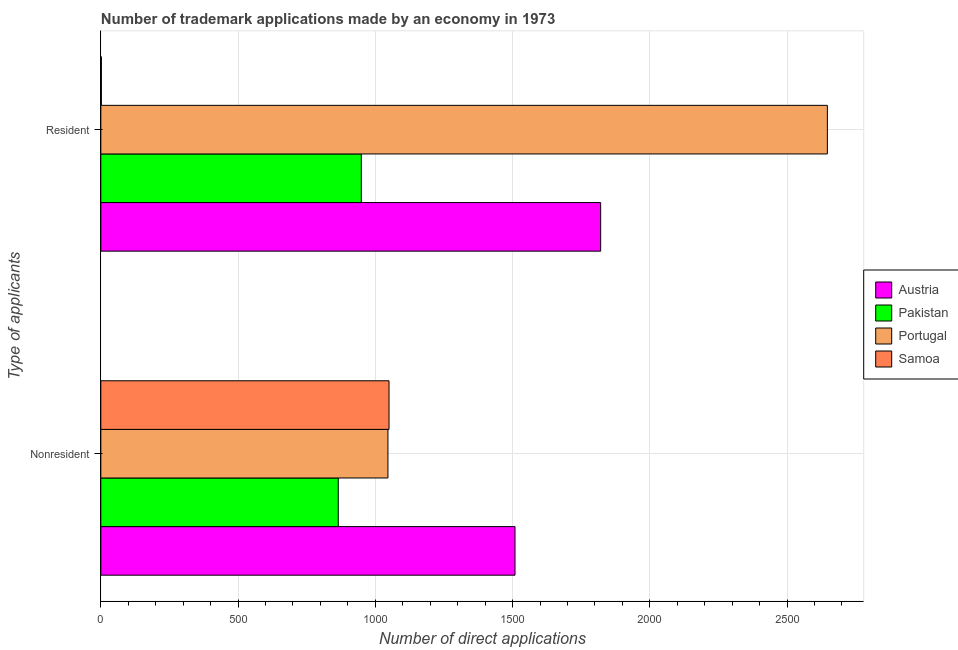How many different coloured bars are there?
Provide a succinct answer. 4. How many groups of bars are there?
Your answer should be compact. 2. Are the number of bars per tick equal to the number of legend labels?
Your answer should be very brief. Yes. Are the number of bars on each tick of the Y-axis equal?
Your response must be concise. Yes. How many bars are there on the 2nd tick from the top?
Your answer should be compact. 4. What is the label of the 1st group of bars from the top?
Offer a very short reply. Resident. What is the number of trademark applications made by non residents in Austria?
Offer a terse response. 1509. Across all countries, what is the maximum number of trademark applications made by non residents?
Keep it short and to the point. 1509. Across all countries, what is the minimum number of trademark applications made by non residents?
Provide a short and direct response. 865. What is the total number of trademark applications made by residents in the graph?
Your answer should be very brief. 5419. What is the difference between the number of trademark applications made by residents in Austria and that in Samoa?
Give a very brief answer. 1819. What is the difference between the number of trademark applications made by residents in Austria and the number of trademark applications made by non residents in Samoa?
Ensure brevity in your answer.  771. What is the average number of trademark applications made by residents per country?
Provide a succinct answer. 1354.75. What is the difference between the number of trademark applications made by non residents and number of trademark applications made by residents in Samoa?
Ensure brevity in your answer.  1048. What is the ratio of the number of trademark applications made by non residents in Portugal to that in Pakistan?
Make the answer very short. 1.21. Is the number of trademark applications made by non residents in Pakistan less than that in Samoa?
Ensure brevity in your answer.  Yes. What does the 1st bar from the top in Nonresident represents?
Ensure brevity in your answer.  Samoa. What does the 4th bar from the bottom in Nonresident represents?
Keep it short and to the point. Samoa. How many bars are there?
Offer a very short reply. 8. Are all the bars in the graph horizontal?
Provide a succinct answer. Yes. What is the difference between two consecutive major ticks on the X-axis?
Provide a succinct answer. 500. Are the values on the major ticks of X-axis written in scientific E-notation?
Your answer should be very brief. No. Does the graph contain any zero values?
Your response must be concise. No. Where does the legend appear in the graph?
Your response must be concise. Center right. How many legend labels are there?
Your answer should be compact. 4. What is the title of the graph?
Offer a terse response. Number of trademark applications made by an economy in 1973. What is the label or title of the X-axis?
Offer a very short reply. Number of direct applications. What is the label or title of the Y-axis?
Give a very brief answer. Type of applicants. What is the Number of direct applications of Austria in Nonresident?
Keep it short and to the point. 1509. What is the Number of direct applications of Pakistan in Nonresident?
Your answer should be compact. 865. What is the Number of direct applications of Portugal in Nonresident?
Give a very brief answer. 1046. What is the Number of direct applications of Samoa in Nonresident?
Make the answer very short. 1050. What is the Number of direct applications in Austria in Resident?
Keep it short and to the point. 1821. What is the Number of direct applications of Pakistan in Resident?
Your answer should be compact. 949. What is the Number of direct applications in Portugal in Resident?
Keep it short and to the point. 2647. What is the Number of direct applications of Samoa in Resident?
Your answer should be compact. 2. Across all Type of applicants, what is the maximum Number of direct applications of Austria?
Keep it short and to the point. 1821. Across all Type of applicants, what is the maximum Number of direct applications in Pakistan?
Your answer should be compact. 949. Across all Type of applicants, what is the maximum Number of direct applications of Portugal?
Offer a terse response. 2647. Across all Type of applicants, what is the maximum Number of direct applications in Samoa?
Your response must be concise. 1050. Across all Type of applicants, what is the minimum Number of direct applications of Austria?
Your response must be concise. 1509. Across all Type of applicants, what is the minimum Number of direct applications of Pakistan?
Offer a very short reply. 865. Across all Type of applicants, what is the minimum Number of direct applications of Portugal?
Offer a terse response. 1046. What is the total Number of direct applications in Austria in the graph?
Your answer should be compact. 3330. What is the total Number of direct applications in Pakistan in the graph?
Offer a terse response. 1814. What is the total Number of direct applications of Portugal in the graph?
Your answer should be very brief. 3693. What is the total Number of direct applications in Samoa in the graph?
Your answer should be compact. 1052. What is the difference between the Number of direct applications of Austria in Nonresident and that in Resident?
Offer a very short reply. -312. What is the difference between the Number of direct applications of Pakistan in Nonresident and that in Resident?
Your answer should be very brief. -84. What is the difference between the Number of direct applications of Portugal in Nonresident and that in Resident?
Offer a terse response. -1601. What is the difference between the Number of direct applications in Samoa in Nonresident and that in Resident?
Offer a very short reply. 1048. What is the difference between the Number of direct applications in Austria in Nonresident and the Number of direct applications in Pakistan in Resident?
Ensure brevity in your answer.  560. What is the difference between the Number of direct applications in Austria in Nonresident and the Number of direct applications in Portugal in Resident?
Offer a very short reply. -1138. What is the difference between the Number of direct applications in Austria in Nonresident and the Number of direct applications in Samoa in Resident?
Offer a terse response. 1507. What is the difference between the Number of direct applications in Pakistan in Nonresident and the Number of direct applications in Portugal in Resident?
Keep it short and to the point. -1782. What is the difference between the Number of direct applications in Pakistan in Nonresident and the Number of direct applications in Samoa in Resident?
Your answer should be very brief. 863. What is the difference between the Number of direct applications of Portugal in Nonresident and the Number of direct applications of Samoa in Resident?
Ensure brevity in your answer.  1044. What is the average Number of direct applications of Austria per Type of applicants?
Your response must be concise. 1665. What is the average Number of direct applications in Pakistan per Type of applicants?
Your answer should be compact. 907. What is the average Number of direct applications in Portugal per Type of applicants?
Provide a short and direct response. 1846.5. What is the average Number of direct applications in Samoa per Type of applicants?
Give a very brief answer. 526. What is the difference between the Number of direct applications of Austria and Number of direct applications of Pakistan in Nonresident?
Ensure brevity in your answer.  644. What is the difference between the Number of direct applications in Austria and Number of direct applications in Portugal in Nonresident?
Offer a terse response. 463. What is the difference between the Number of direct applications of Austria and Number of direct applications of Samoa in Nonresident?
Your answer should be compact. 459. What is the difference between the Number of direct applications of Pakistan and Number of direct applications of Portugal in Nonresident?
Offer a very short reply. -181. What is the difference between the Number of direct applications of Pakistan and Number of direct applications of Samoa in Nonresident?
Your answer should be very brief. -185. What is the difference between the Number of direct applications in Portugal and Number of direct applications in Samoa in Nonresident?
Make the answer very short. -4. What is the difference between the Number of direct applications of Austria and Number of direct applications of Pakistan in Resident?
Make the answer very short. 872. What is the difference between the Number of direct applications in Austria and Number of direct applications in Portugal in Resident?
Your answer should be compact. -826. What is the difference between the Number of direct applications of Austria and Number of direct applications of Samoa in Resident?
Keep it short and to the point. 1819. What is the difference between the Number of direct applications in Pakistan and Number of direct applications in Portugal in Resident?
Provide a succinct answer. -1698. What is the difference between the Number of direct applications in Pakistan and Number of direct applications in Samoa in Resident?
Offer a terse response. 947. What is the difference between the Number of direct applications in Portugal and Number of direct applications in Samoa in Resident?
Offer a terse response. 2645. What is the ratio of the Number of direct applications of Austria in Nonresident to that in Resident?
Your answer should be compact. 0.83. What is the ratio of the Number of direct applications in Pakistan in Nonresident to that in Resident?
Give a very brief answer. 0.91. What is the ratio of the Number of direct applications in Portugal in Nonresident to that in Resident?
Ensure brevity in your answer.  0.4. What is the ratio of the Number of direct applications in Samoa in Nonresident to that in Resident?
Ensure brevity in your answer.  525. What is the difference between the highest and the second highest Number of direct applications of Austria?
Provide a succinct answer. 312. What is the difference between the highest and the second highest Number of direct applications of Pakistan?
Provide a short and direct response. 84. What is the difference between the highest and the second highest Number of direct applications in Portugal?
Give a very brief answer. 1601. What is the difference between the highest and the second highest Number of direct applications in Samoa?
Provide a short and direct response. 1048. What is the difference between the highest and the lowest Number of direct applications in Austria?
Your answer should be compact. 312. What is the difference between the highest and the lowest Number of direct applications of Portugal?
Provide a short and direct response. 1601. What is the difference between the highest and the lowest Number of direct applications in Samoa?
Offer a very short reply. 1048. 